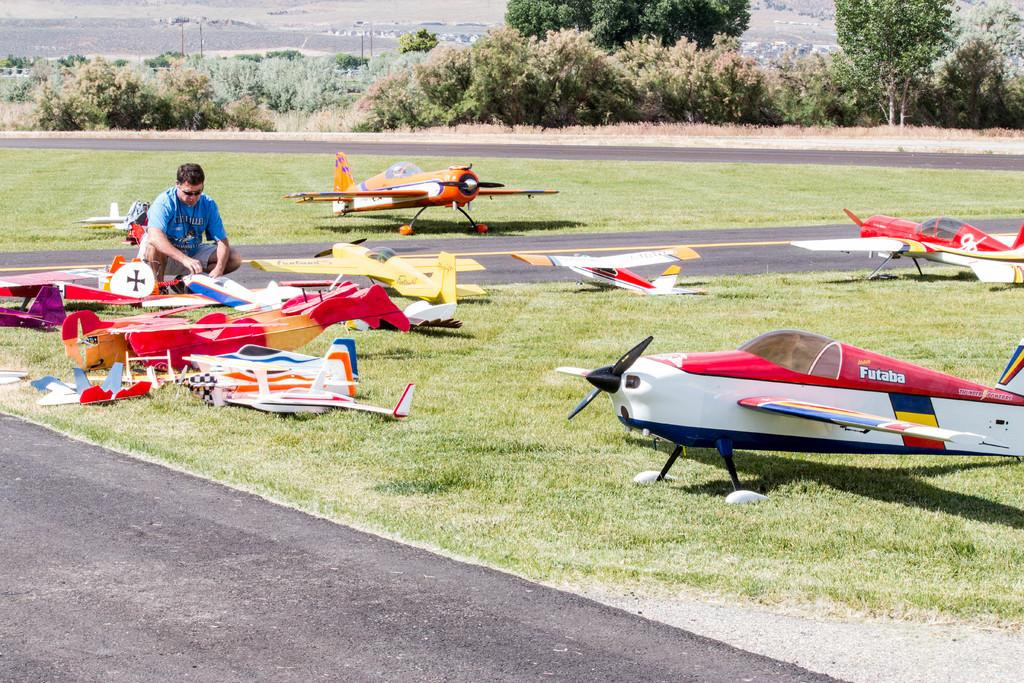<image>
Describe the image concisely. A man is putting together a Futaba model airplane. 